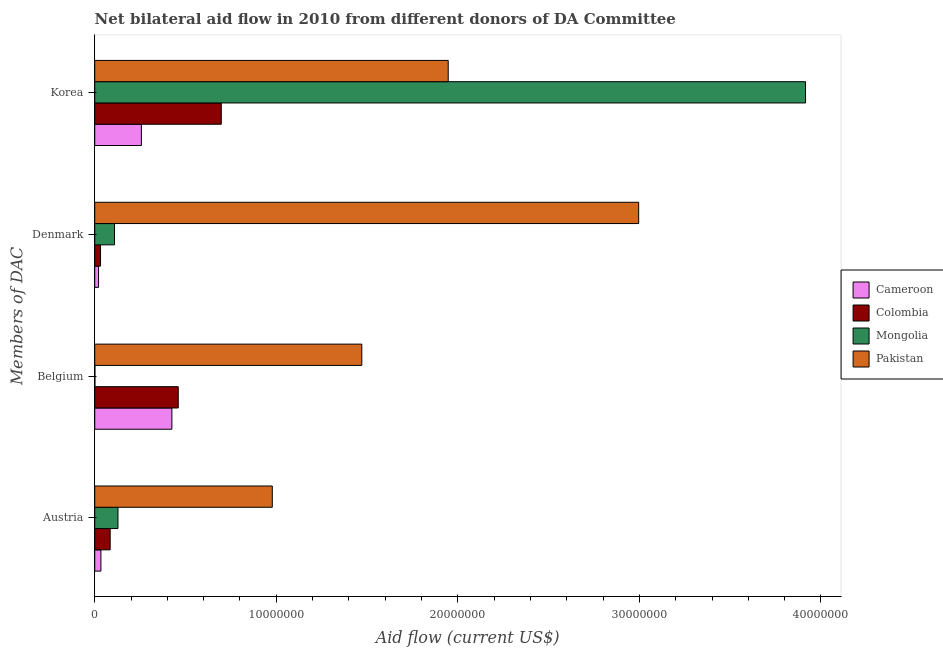Are the number of bars on each tick of the Y-axis equal?
Make the answer very short. Yes. What is the label of the 4th group of bars from the top?
Your answer should be compact. Austria. What is the amount of aid given by belgium in Cameroon?
Your answer should be compact. 4.25e+06. Across all countries, what is the maximum amount of aid given by korea?
Give a very brief answer. 3.92e+07. Across all countries, what is the minimum amount of aid given by austria?
Keep it short and to the point. 3.40e+05. In which country was the amount of aid given by korea minimum?
Offer a terse response. Cameroon. What is the total amount of aid given by korea in the graph?
Your answer should be very brief. 6.82e+07. What is the difference between the amount of aid given by denmark in Mongolia and that in Pakistan?
Make the answer very short. -2.89e+07. What is the difference between the amount of aid given by austria in Mongolia and the amount of aid given by belgium in Cameroon?
Your answer should be compact. -2.97e+06. What is the average amount of aid given by denmark per country?
Your response must be concise. 7.90e+06. What is the difference between the amount of aid given by denmark and amount of aid given by korea in Cameroon?
Make the answer very short. -2.36e+06. In how many countries, is the amount of aid given by denmark greater than 14000000 US$?
Offer a terse response. 1. What is the ratio of the amount of aid given by korea in Mongolia to that in Pakistan?
Provide a succinct answer. 2.01. Is the amount of aid given by korea in Cameroon less than that in Mongolia?
Offer a very short reply. Yes. Is the difference between the amount of aid given by denmark in Mongolia and Colombia greater than the difference between the amount of aid given by austria in Mongolia and Colombia?
Provide a succinct answer. Yes. What is the difference between the highest and the second highest amount of aid given by belgium?
Provide a short and direct response. 1.01e+07. What is the difference between the highest and the lowest amount of aid given by denmark?
Your response must be concise. 2.98e+07. Is it the case that in every country, the sum of the amount of aid given by denmark and amount of aid given by korea is greater than the sum of amount of aid given by austria and amount of aid given by belgium?
Your response must be concise. Yes. What does the 2nd bar from the top in Belgium represents?
Provide a short and direct response. Mongolia. How many countries are there in the graph?
Provide a succinct answer. 4. Are the values on the major ticks of X-axis written in scientific E-notation?
Make the answer very short. No. Does the graph contain any zero values?
Offer a terse response. No. Does the graph contain grids?
Offer a very short reply. No. How many legend labels are there?
Your answer should be compact. 4. What is the title of the graph?
Provide a succinct answer. Net bilateral aid flow in 2010 from different donors of DA Committee. What is the label or title of the X-axis?
Keep it short and to the point. Aid flow (current US$). What is the label or title of the Y-axis?
Keep it short and to the point. Members of DAC. What is the Aid flow (current US$) of Colombia in Austria?
Provide a succinct answer. 8.50e+05. What is the Aid flow (current US$) of Mongolia in Austria?
Provide a short and direct response. 1.28e+06. What is the Aid flow (current US$) of Pakistan in Austria?
Give a very brief answer. 9.78e+06. What is the Aid flow (current US$) of Cameroon in Belgium?
Keep it short and to the point. 4.25e+06. What is the Aid flow (current US$) in Colombia in Belgium?
Provide a short and direct response. 4.60e+06. What is the Aid flow (current US$) of Mongolia in Belgium?
Your answer should be compact. 10000. What is the Aid flow (current US$) of Pakistan in Belgium?
Your response must be concise. 1.47e+07. What is the Aid flow (current US$) in Cameroon in Denmark?
Your answer should be very brief. 2.10e+05. What is the Aid flow (current US$) of Mongolia in Denmark?
Your answer should be very brief. 1.09e+06. What is the Aid flow (current US$) in Pakistan in Denmark?
Offer a very short reply. 3.00e+07. What is the Aid flow (current US$) in Cameroon in Korea?
Provide a short and direct response. 2.57e+06. What is the Aid flow (current US$) in Colombia in Korea?
Your answer should be compact. 6.97e+06. What is the Aid flow (current US$) of Mongolia in Korea?
Your answer should be very brief. 3.92e+07. What is the Aid flow (current US$) of Pakistan in Korea?
Keep it short and to the point. 1.95e+07. Across all Members of DAC, what is the maximum Aid flow (current US$) in Cameroon?
Your response must be concise. 4.25e+06. Across all Members of DAC, what is the maximum Aid flow (current US$) of Colombia?
Your answer should be very brief. 6.97e+06. Across all Members of DAC, what is the maximum Aid flow (current US$) of Mongolia?
Provide a short and direct response. 3.92e+07. Across all Members of DAC, what is the maximum Aid flow (current US$) of Pakistan?
Your answer should be compact. 3.00e+07. Across all Members of DAC, what is the minimum Aid flow (current US$) of Cameroon?
Your response must be concise. 2.10e+05. Across all Members of DAC, what is the minimum Aid flow (current US$) of Colombia?
Provide a short and direct response. 3.20e+05. Across all Members of DAC, what is the minimum Aid flow (current US$) in Pakistan?
Give a very brief answer. 9.78e+06. What is the total Aid flow (current US$) of Cameroon in the graph?
Provide a succinct answer. 7.37e+06. What is the total Aid flow (current US$) of Colombia in the graph?
Keep it short and to the point. 1.27e+07. What is the total Aid flow (current US$) in Mongolia in the graph?
Make the answer very short. 4.15e+07. What is the total Aid flow (current US$) in Pakistan in the graph?
Your answer should be compact. 7.39e+07. What is the difference between the Aid flow (current US$) in Cameroon in Austria and that in Belgium?
Make the answer very short. -3.91e+06. What is the difference between the Aid flow (current US$) in Colombia in Austria and that in Belgium?
Give a very brief answer. -3.75e+06. What is the difference between the Aid flow (current US$) of Mongolia in Austria and that in Belgium?
Provide a short and direct response. 1.27e+06. What is the difference between the Aid flow (current US$) in Pakistan in Austria and that in Belgium?
Give a very brief answer. -4.93e+06. What is the difference between the Aid flow (current US$) of Cameroon in Austria and that in Denmark?
Your response must be concise. 1.30e+05. What is the difference between the Aid flow (current US$) in Colombia in Austria and that in Denmark?
Your answer should be compact. 5.30e+05. What is the difference between the Aid flow (current US$) of Mongolia in Austria and that in Denmark?
Provide a short and direct response. 1.90e+05. What is the difference between the Aid flow (current US$) of Pakistan in Austria and that in Denmark?
Make the answer very short. -2.02e+07. What is the difference between the Aid flow (current US$) of Cameroon in Austria and that in Korea?
Offer a terse response. -2.23e+06. What is the difference between the Aid flow (current US$) of Colombia in Austria and that in Korea?
Make the answer very short. -6.12e+06. What is the difference between the Aid flow (current US$) in Mongolia in Austria and that in Korea?
Ensure brevity in your answer.  -3.79e+07. What is the difference between the Aid flow (current US$) of Pakistan in Austria and that in Korea?
Your answer should be compact. -9.69e+06. What is the difference between the Aid flow (current US$) in Cameroon in Belgium and that in Denmark?
Your answer should be very brief. 4.04e+06. What is the difference between the Aid flow (current US$) of Colombia in Belgium and that in Denmark?
Ensure brevity in your answer.  4.28e+06. What is the difference between the Aid flow (current US$) in Mongolia in Belgium and that in Denmark?
Ensure brevity in your answer.  -1.08e+06. What is the difference between the Aid flow (current US$) of Pakistan in Belgium and that in Denmark?
Ensure brevity in your answer.  -1.52e+07. What is the difference between the Aid flow (current US$) of Cameroon in Belgium and that in Korea?
Make the answer very short. 1.68e+06. What is the difference between the Aid flow (current US$) of Colombia in Belgium and that in Korea?
Make the answer very short. -2.37e+06. What is the difference between the Aid flow (current US$) of Mongolia in Belgium and that in Korea?
Offer a terse response. -3.91e+07. What is the difference between the Aid flow (current US$) in Pakistan in Belgium and that in Korea?
Your answer should be very brief. -4.76e+06. What is the difference between the Aid flow (current US$) of Cameroon in Denmark and that in Korea?
Ensure brevity in your answer.  -2.36e+06. What is the difference between the Aid flow (current US$) in Colombia in Denmark and that in Korea?
Your answer should be very brief. -6.65e+06. What is the difference between the Aid flow (current US$) of Mongolia in Denmark and that in Korea?
Offer a very short reply. -3.81e+07. What is the difference between the Aid flow (current US$) of Pakistan in Denmark and that in Korea?
Give a very brief answer. 1.05e+07. What is the difference between the Aid flow (current US$) of Cameroon in Austria and the Aid flow (current US$) of Colombia in Belgium?
Provide a succinct answer. -4.26e+06. What is the difference between the Aid flow (current US$) of Cameroon in Austria and the Aid flow (current US$) of Mongolia in Belgium?
Offer a terse response. 3.30e+05. What is the difference between the Aid flow (current US$) of Cameroon in Austria and the Aid flow (current US$) of Pakistan in Belgium?
Your answer should be compact. -1.44e+07. What is the difference between the Aid flow (current US$) of Colombia in Austria and the Aid flow (current US$) of Mongolia in Belgium?
Offer a terse response. 8.40e+05. What is the difference between the Aid flow (current US$) in Colombia in Austria and the Aid flow (current US$) in Pakistan in Belgium?
Your answer should be compact. -1.39e+07. What is the difference between the Aid flow (current US$) of Mongolia in Austria and the Aid flow (current US$) of Pakistan in Belgium?
Ensure brevity in your answer.  -1.34e+07. What is the difference between the Aid flow (current US$) in Cameroon in Austria and the Aid flow (current US$) in Mongolia in Denmark?
Offer a terse response. -7.50e+05. What is the difference between the Aid flow (current US$) in Cameroon in Austria and the Aid flow (current US$) in Pakistan in Denmark?
Offer a terse response. -2.96e+07. What is the difference between the Aid flow (current US$) in Colombia in Austria and the Aid flow (current US$) in Pakistan in Denmark?
Offer a very short reply. -2.91e+07. What is the difference between the Aid flow (current US$) of Mongolia in Austria and the Aid flow (current US$) of Pakistan in Denmark?
Provide a short and direct response. -2.87e+07. What is the difference between the Aid flow (current US$) in Cameroon in Austria and the Aid flow (current US$) in Colombia in Korea?
Your answer should be compact. -6.63e+06. What is the difference between the Aid flow (current US$) of Cameroon in Austria and the Aid flow (current US$) of Mongolia in Korea?
Give a very brief answer. -3.88e+07. What is the difference between the Aid flow (current US$) in Cameroon in Austria and the Aid flow (current US$) in Pakistan in Korea?
Ensure brevity in your answer.  -1.91e+07. What is the difference between the Aid flow (current US$) of Colombia in Austria and the Aid flow (current US$) of Mongolia in Korea?
Your answer should be very brief. -3.83e+07. What is the difference between the Aid flow (current US$) in Colombia in Austria and the Aid flow (current US$) in Pakistan in Korea?
Offer a very short reply. -1.86e+07. What is the difference between the Aid flow (current US$) of Mongolia in Austria and the Aid flow (current US$) of Pakistan in Korea?
Keep it short and to the point. -1.82e+07. What is the difference between the Aid flow (current US$) in Cameroon in Belgium and the Aid flow (current US$) in Colombia in Denmark?
Provide a short and direct response. 3.93e+06. What is the difference between the Aid flow (current US$) of Cameroon in Belgium and the Aid flow (current US$) of Mongolia in Denmark?
Ensure brevity in your answer.  3.16e+06. What is the difference between the Aid flow (current US$) in Cameroon in Belgium and the Aid flow (current US$) in Pakistan in Denmark?
Offer a very short reply. -2.57e+07. What is the difference between the Aid flow (current US$) in Colombia in Belgium and the Aid flow (current US$) in Mongolia in Denmark?
Keep it short and to the point. 3.51e+06. What is the difference between the Aid flow (current US$) of Colombia in Belgium and the Aid flow (current US$) of Pakistan in Denmark?
Give a very brief answer. -2.54e+07. What is the difference between the Aid flow (current US$) in Mongolia in Belgium and the Aid flow (current US$) in Pakistan in Denmark?
Your answer should be very brief. -3.00e+07. What is the difference between the Aid flow (current US$) in Cameroon in Belgium and the Aid flow (current US$) in Colombia in Korea?
Give a very brief answer. -2.72e+06. What is the difference between the Aid flow (current US$) in Cameroon in Belgium and the Aid flow (current US$) in Mongolia in Korea?
Offer a terse response. -3.49e+07. What is the difference between the Aid flow (current US$) in Cameroon in Belgium and the Aid flow (current US$) in Pakistan in Korea?
Your answer should be compact. -1.52e+07. What is the difference between the Aid flow (current US$) in Colombia in Belgium and the Aid flow (current US$) in Mongolia in Korea?
Give a very brief answer. -3.46e+07. What is the difference between the Aid flow (current US$) of Colombia in Belgium and the Aid flow (current US$) of Pakistan in Korea?
Ensure brevity in your answer.  -1.49e+07. What is the difference between the Aid flow (current US$) of Mongolia in Belgium and the Aid flow (current US$) of Pakistan in Korea?
Your response must be concise. -1.95e+07. What is the difference between the Aid flow (current US$) of Cameroon in Denmark and the Aid flow (current US$) of Colombia in Korea?
Keep it short and to the point. -6.76e+06. What is the difference between the Aid flow (current US$) in Cameroon in Denmark and the Aid flow (current US$) in Mongolia in Korea?
Offer a terse response. -3.89e+07. What is the difference between the Aid flow (current US$) of Cameroon in Denmark and the Aid flow (current US$) of Pakistan in Korea?
Make the answer very short. -1.93e+07. What is the difference between the Aid flow (current US$) in Colombia in Denmark and the Aid flow (current US$) in Mongolia in Korea?
Offer a terse response. -3.88e+07. What is the difference between the Aid flow (current US$) of Colombia in Denmark and the Aid flow (current US$) of Pakistan in Korea?
Make the answer very short. -1.92e+07. What is the difference between the Aid flow (current US$) in Mongolia in Denmark and the Aid flow (current US$) in Pakistan in Korea?
Your answer should be very brief. -1.84e+07. What is the average Aid flow (current US$) in Cameroon per Members of DAC?
Ensure brevity in your answer.  1.84e+06. What is the average Aid flow (current US$) of Colombia per Members of DAC?
Keep it short and to the point. 3.18e+06. What is the average Aid flow (current US$) in Mongolia per Members of DAC?
Your answer should be very brief. 1.04e+07. What is the average Aid flow (current US$) in Pakistan per Members of DAC?
Offer a terse response. 1.85e+07. What is the difference between the Aid flow (current US$) of Cameroon and Aid flow (current US$) of Colombia in Austria?
Provide a short and direct response. -5.10e+05. What is the difference between the Aid flow (current US$) in Cameroon and Aid flow (current US$) in Mongolia in Austria?
Ensure brevity in your answer.  -9.40e+05. What is the difference between the Aid flow (current US$) in Cameroon and Aid flow (current US$) in Pakistan in Austria?
Keep it short and to the point. -9.44e+06. What is the difference between the Aid flow (current US$) in Colombia and Aid flow (current US$) in Mongolia in Austria?
Make the answer very short. -4.30e+05. What is the difference between the Aid flow (current US$) in Colombia and Aid flow (current US$) in Pakistan in Austria?
Provide a succinct answer. -8.93e+06. What is the difference between the Aid flow (current US$) in Mongolia and Aid flow (current US$) in Pakistan in Austria?
Your answer should be compact. -8.50e+06. What is the difference between the Aid flow (current US$) in Cameroon and Aid flow (current US$) in Colombia in Belgium?
Offer a very short reply. -3.50e+05. What is the difference between the Aid flow (current US$) in Cameroon and Aid flow (current US$) in Mongolia in Belgium?
Your response must be concise. 4.24e+06. What is the difference between the Aid flow (current US$) in Cameroon and Aid flow (current US$) in Pakistan in Belgium?
Offer a very short reply. -1.05e+07. What is the difference between the Aid flow (current US$) in Colombia and Aid flow (current US$) in Mongolia in Belgium?
Your answer should be compact. 4.59e+06. What is the difference between the Aid flow (current US$) in Colombia and Aid flow (current US$) in Pakistan in Belgium?
Ensure brevity in your answer.  -1.01e+07. What is the difference between the Aid flow (current US$) of Mongolia and Aid flow (current US$) of Pakistan in Belgium?
Offer a very short reply. -1.47e+07. What is the difference between the Aid flow (current US$) of Cameroon and Aid flow (current US$) of Colombia in Denmark?
Your answer should be compact. -1.10e+05. What is the difference between the Aid flow (current US$) of Cameroon and Aid flow (current US$) of Mongolia in Denmark?
Offer a very short reply. -8.80e+05. What is the difference between the Aid flow (current US$) in Cameroon and Aid flow (current US$) in Pakistan in Denmark?
Your response must be concise. -2.98e+07. What is the difference between the Aid flow (current US$) in Colombia and Aid flow (current US$) in Mongolia in Denmark?
Offer a terse response. -7.70e+05. What is the difference between the Aid flow (current US$) in Colombia and Aid flow (current US$) in Pakistan in Denmark?
Your response must be concise. -2.96e+07. What is the difference between the Aid flow (current US$) of Mongolia and Aid flow (current US$) of Pakistan in Denmark?
Provide a succinct answer. -2.89e+07. What is the difference between the Aid flow (current US$) of Cameroon and Aid flow (current US$) of Colombia in Korea?
Your answer should be compact. -4.40e+06. What is the difference between the Aid flow (current US$) of Cameroon and Aid flow (current US$) of Mongolia in Korea?
Provide a short and direct response. -3.66e+07. What is the difference between the Aid flow (current US$) in Cameroon and Aid flow (current US$) in Pakistan in Korea?
Your answer should be compact. -1.69e+07. What is the difference between the Aid flow (current US$) in Colombia and Aid flow (current US$) in Mongolia in Korea?
Your response must be concise. -3.22e+07. What is the difference between the Aid flow (current US$) in Colombia and Aid flow (current US$) in Pakistan in Korea?
Ensure brevity in your answer.  -1.25e+07. What is the difference between the Aid flow (current US$) of Mongolia and Aid flow (current US$) of Pakistan in Korea?
Provide a succinct answer. 1.97e+07. What is the ratio of the Aid flow (current US$) of Colombia in Austria to that in Belgium?
Provide a succinct answer. 0.18. What is the ratio of the Aid flow (current US$) of Mongolia in Austria to that in Belgium?
Offer a terse response. 128. What is the ratio of the Aid flow (current US$) in Pakistan in Austria to that in Belgium?
Your response must be concise. 0.66. What is the ratio of the Aid flow (current US$) of Cameroon in Austria to that in Denmark?
Your answer should be compact. 1.62. What is the ratio of the Aid flow (current US$) of Colombia in Austria to that in Denmark?
Give a very brief answer. 2.66. What is the ratio of the Aid flow (current US$) of Mongolia in Austria to that in Denmark?
Offer a terse response. 1.17. What is the ratio of the Aid flow (current US$) in Pakistan in Austria to that in Denmark?
Your response must be concise. 0.33. What is the ratio of the Aid flow (current US$) of Cameroon in Austria to that in Korea?
Your answer should be compact. 0.13. What is the ratio of the Aid flow (current US$) of Colombia in Austria to that in Korea?
Offer a very short reply. 0.12. What is the ratio of the Aid flow (current US$) of Mongolia in Austria to that in Korea?
Offer a terse response. 0.03. What is the ratio of the Aid flow (current US$) in Pakistan in Austria to that in Korea?
Give a very brief answer. 0.5. What is the ratio of the Aid flow (current US$) of Cameroon in Belgium to that in Denmark?
Offer a terse response. 20.24. What is the ratio of the Aid flow (current US$) of Colombia in Belgium to that in Denmark?
Your answer should be compact. 14.38. What is the ratio of the Aid flow (current US$) in Mongolia in Belgium to that in Denmark?
Your answer should be compact. 0.01. What is the ratio of the Aid flow (current US$) of Pakistan in Belgium to that in Denmark?
Your answer should be very brief. 0.49. What is the ratio of the Aid flow (current US$) of Cameroon in Belgium to that in Korea?
Offer a terse response. 1.65. What is the ratio of the Aid flow (current US$) in Colombia in Belgium to that in Korea?
Keep it short and to the point. 0.66. What is the ratio of the Aid flow (current US$) of Pakistan in Belgium to that in Korea?
Ensure brevity in your answer.  0.76. What is the ratio of the Aid flow (current US$) in Cameroon in Denmark to that in Korea?
Provide a succinct answer. 0.08. What is the ratio of the Aid flow (current US$) in Colombia in Denmark to that in Korea?
Your response must be concise. 0.05. What is the ratio of the Aid flow (current US$) in Mongolia in Denmark to that in Korea?
Keep it short and to the point. 0.03. What is the ratio of the Aid flow (current US$) in Pakistan in Denmark to that in Korea?
Your answer should be very brief. 1.54. What is the difference between the highest and the second highest Aid flow (current US$) in Cameroon?
Give a very brief answer. 1.68e+06. What is the difference between the highest and the second highest Aid flow (current US$) of Colombia?
Give a very brief answer. 2.37e+06. What is the difference between the highest and the second highest Aid flow (current US$) of Mongolia?
Offer a terse response. 3.79e+07. What is the difference between the highest and the second highest Aid flow (current US$) of Pakistan?
Ensure brevity in your answer.  1.05e+07. What is the difference between the highest and the lowest Aid flow (current US$) in Cameroon?
Provide a short and direct response. 4.04e+06. What is the difference between the highest and the lowest Aid flow (current US$) in Colombia?
Offer a terse response. 6.65e+06. What is the difference between the highest and the lowest Aid flow (current US$) of Mongolia?
Your answer should be compact. 3.91e+07. What is the difference between the highest and the lowest Aid flow (current US$) of Pakistan?
Offer a very short reply. 2.02e+07. 